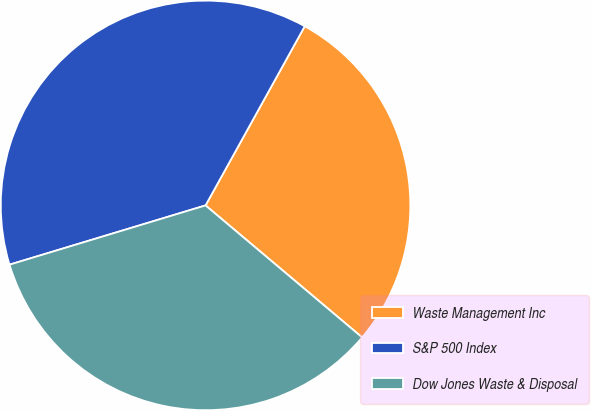Convert chart to OTSL. <chart><loc_0><loc_0><loc_500><loc_500><pie_chart><fcel>Waste Management Inc<fcel>S&P 500 Index<fcel>Dow Jones Waste & Disposal<nl><fcel>28.1%<fcel>37.72%<fcel>34.18%<nl></chart> 